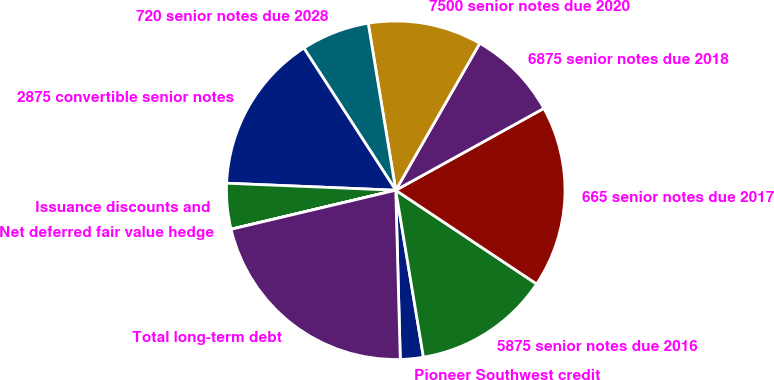<chart> <loc_0><loc_0><loc_500><loc_500><pie_chart><fcel>Pioneer Southwest credit<fcel>5875 senior notes due 2016<fcel>665 senior notes due 2017<fcel>6875 senior notes due 2018<fcel>7500 senior notes due 2020<fcel>720 senior notes due 2028<fcel>2875 convertible senior notes<fcel>Issuance discounts and<fcel>Net deferred fair value hedge<fcel>Total long-term debt<nl><fcel>2.19%<fcel>13.04%<fcel>17.38%<fcel>8.7%<fcel>10.87%<fcel>6.53%<fcel>15.21%<fcel>4.36%<fcel>0.01%<fcel>21.72%<nl></chart> 